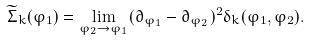<formula> <loc_0><loc_0><loc_500><loc_500>\widetilde { \Sigma } _ { k } ( \varphi _ { 1 } ) = \lim _ { \varphi _ { 2 } \to \varphi _ { 1 } } ( \partial _ { \varphi _ { 1 } } - \partial _ { \varphi _ { 2 } } ) ^ { 2 } \delta _ { k } ( \varphi _ { 1 } , \varphi _ { 2 } ) .</formula> 